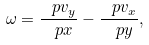<formula> <loc_0><loc_0><loc_500><loc_500>\omega = \frac { \ p v _ { y } } { \ p x } - \frac { \ p v _ { x } } { \ p y } ,</formula> 